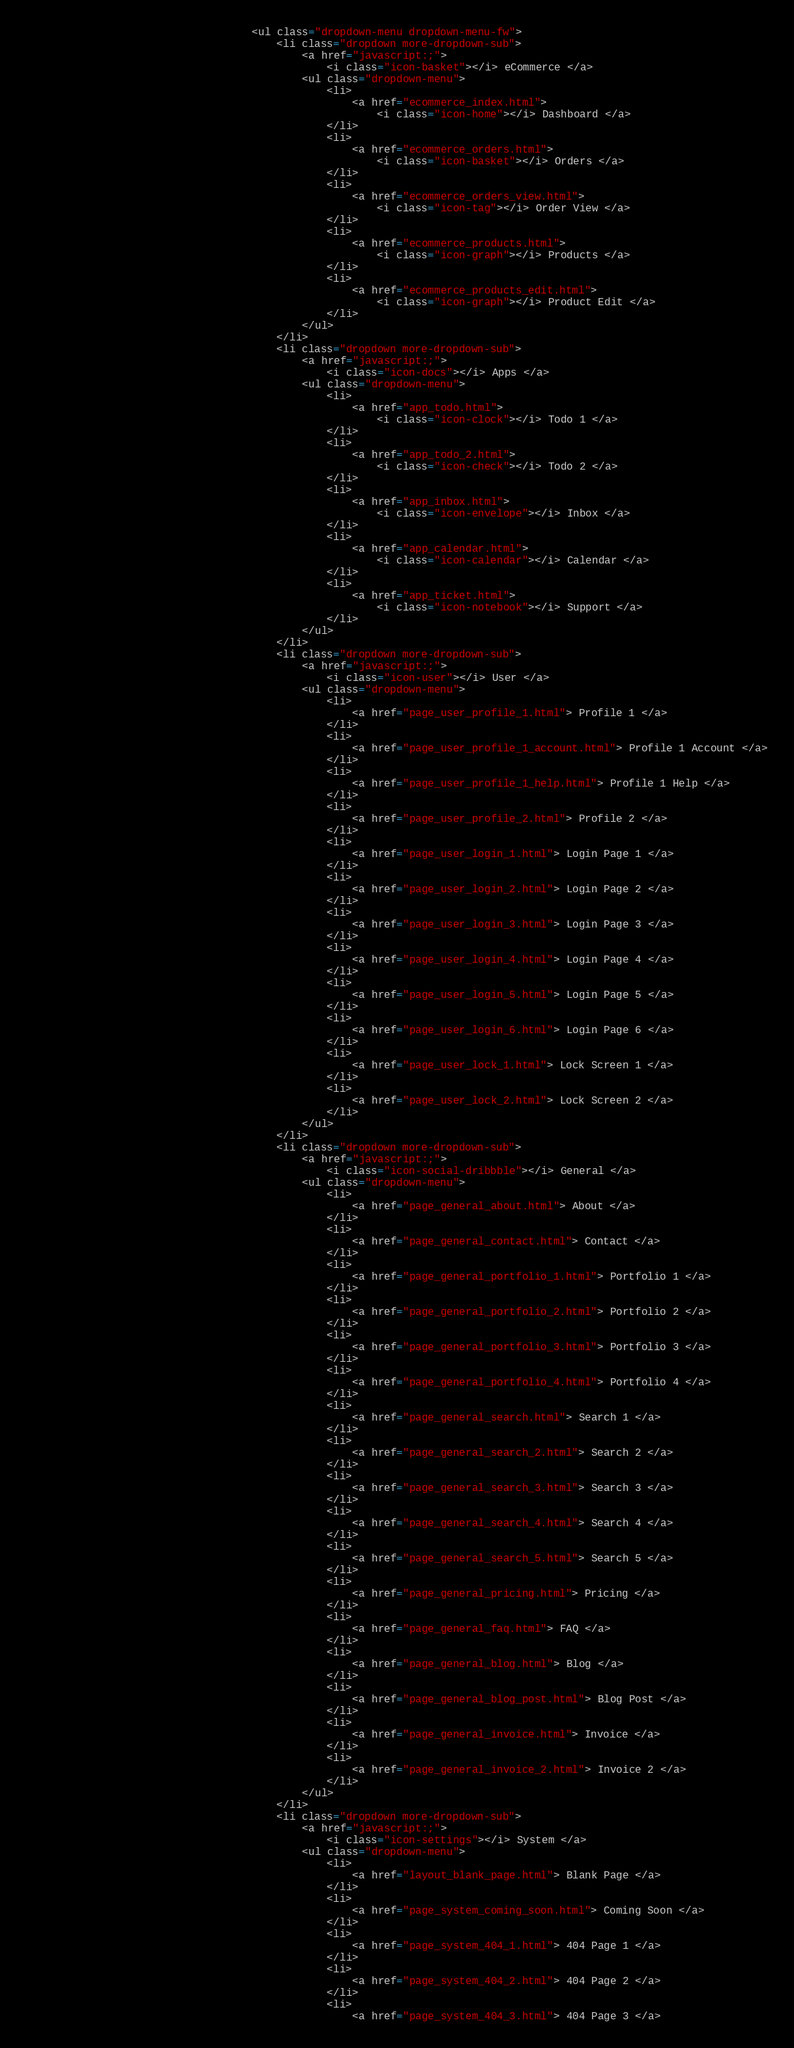<code> <loc_0><loc_0><loc_500><loc_500><_HTML_>                                    <ul class="dropdown-menu dropdown-menu-fw">
                                        <li class="dropdown more-dropdown-sub">
                                            <a href="javascript:;">
                                                <i class="icon-basket"></i> eCommerce </a>
                                            <ul class="dropdown-menu">
                                                <li>
                                                    <a href="ecommerce_index.html">
                                                        <i class="icon-home"></i> Dashboard </a>
                                                </li>
                                                <li>
                                                    <a href="ecommerce_orders.html">
                                                        <i class="icon-basket"></i> Orders </a>
                                                </li>
                                                <li>
                                                    <a href="ecommerce_orders_view.html">
                                                        <i class="icon-tag"></i> Order View </a>
                                                </li>
                                                <li>
                                                    <a href="ecommerce_products.html">
                                                        <i class="icon-graph"></i> Products </a>
                                                </li>
                                                <li>
                                                    <a href="ecommerce_products_edit.html">
                                                        <i class="icon-graph"></i> Product Edit </a>
                                                </li>
                                            </ul>
                                        </li>
                                        <li class="dropdown more-dropdown-sub">
                                            <a href="javascript:;">
                                                <i class="icon-docs"></i> Apps </a>
                                            <ul class="dropdown-menu">
                                                <li>
                                                    <a href="app_todo.html">
                                                        <i class="icon-clock"></i> Todo 1 </a>
                                                </li>
                                                <li>
                                                    <a href="app_todo_2.html">
                                                        <i class="icon-check"></i> Todo 2 </a>
                                                </li>
                                                <li>
                                                    <a href="app_inbox.html">
                                                        <i class="icon-envelope"></i> Inbox </a>
                                                </li>
                                                <li>
                                                    <a href="app_calendar.html">
                                                        <i class="icon-calendar"></i> Calendar </a>
                                                </li>
                                                <li>
                                                    <a href="app_ticket.html">
                                                        <i class="icon-notebook"></i> Support </a>
                                                </li>
                                            </ul>
                                        </li>
                                        <li class="dropdown more-dropdown-sub">
                                            <a href="javascript:;">
                                                <i class="icon-user"></i> User </a>
                                            <ul class="dropdown-menu">
                                                <li>
                                                    <a href="page_user_profile_1.html"> Profile 1 </a>
                                                </li>
                                                <li>
                                                    <a href="page_user_profile_1_account.html"> Profile 1 Account </a>
                                                </li>
                                                <li>
                                                    <a href="page_user_profile_1_help.html"> Profile 1 Help </a>
                                                </li>
                                                <li>
                                                    <a href="page_user_profile_2.html"> Profile 2 </a>
                                                </li>
                                                <li>
                                                    <a href="page_user_login_1.html"> Login Page 1 </a>
                                                </li>
                                                <li>
                                                    <a href="page_user_login_2.html"> Login Page 2 </a>
                                                </li>
                                                <li>
                                                    <a href="page_user_login_3.html"> Login Page 3 </a>
                                                </li>
                                                <li>
                                                    <a href="page_user_login_4.html"> Login Page 4 </a>
                                                </li>
                                                <li>
                                                    <a href="page_user_login_5.html"> Login Page 5 </a>
                                                </li>
                                                <li>
                                                    <a href="page_user_login_6.html"> Login Page 6 </a>
                                                </li>
                                                <li>
                                                    <a href="page_user_lock_1.html"> Lock Screen 1 </a>
                                                </li>
                                                <li>
                                                    <a href="page_user_lock_2.html"> Lock Screen 2 </a>
                                                </li>
                                            </ul>
                                        </li>
                                        <li class="dropdown more-dropdown-sub">
                                            <a href="javascript:;">
                                                <i class="icon-social-dribbble"></i> General </a>
                                            <ul class="dropdown-menu">
                                                <li>
                                                    <a href="page_general_about.html"> About </a>
                                                </li>
                                                <li>
                                                    <a href="page_general_contact.html"> Contact </a>
                                                </li>
                                                <li>
                                                    <a href="page_general_portfolio_1.html"> Portfolio 1 </a>
                                                </li>
                                                <li>
                                                    <a href="page_general_portfolio_2.html"> Portfolio 2 </a>
                                                </li>
                                                <li>
                                                    <a href="page_general_portfolio_3.html"> Portfolio 3 </a>
                                                </li>
                                                <li>
                                                    <a href="page_general_portfolio_4.html"> Portfolio 4 </a>
                                                </li>
                                                <li>
                                                    <a href="page_general_search.html"> Search 1 </a>
                                                </li>
                                                <li>
                                                    <a href="page_general_search_2.html"> Search 2 </a>
                                                </li>
                                                <li>
                                                    <a href="page_general_search_3.html"> Search 3 </a>
                                                </li>
                                                <li>
                                                    <a href="page_general_search_4.html"> Search 4 </a>
                                                </li>
                                                <li>
                                                    <a href="page_general_search_5.html"> Search 5 </a>
                                                </li>
                                                <li>
                                                    <a href="page_general_pricing.html"> Pricing </a>
                                                </li>
                                                <li>
                                                    <a href="page_general_faq.html"> FAQ </a>
                                                </li>
                                                <li>
                                                    <a href="page_general_blog.html"> Blog </a>
                                                </li>
                                                <li>
                                                    <a href="page_general_blog_post.html"> Blog Post </a>
                                                </li>
                                                <li>
                                                    <a href="page_general_invoice.html"> Invoice </a>
                                                </li>
                                                <li>
                                                    <a href="page_general_invoice_2.html"> Invoice 2 </a>
                                                </li>
                                            </ul>
                                        </li>
                                        <li class="dropdown more-dropdown-sub">
                                            <a href="javascript:;">
                                                <i class="icon-settings"></i> System </a>
                                            <ul class="dropdown-menu">
                                                <li>
                                                    <a href="layout_blank_page.html"> Blank Page </a>
                                                </li>
                                                <li>
                                                    <a href="page_system_coming_soon.html"> Coming Soon </a>
                                                </li>
                                                <li>
                                                    <a href="page_system_404_1.html"> 404 Page 1 </a>
                                                </li>
                                                <li>
                                                    <a href="page_system_404_2.html"> 404 Page 2 </a>
                                                </li>
                                                <li>
                                                    <a href="page_system_404_3.html"> 404 Page 3 </a></code> 